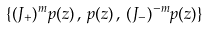<formula> <loc_0><loc_0><loc_500><loc_500>\{ ( J _ { + } ) ^ { m } p ( z ) \, , \, p ( z ) \, , \, ( J _ { - } ) ^ { - m } p ( z ) \}</formula> 